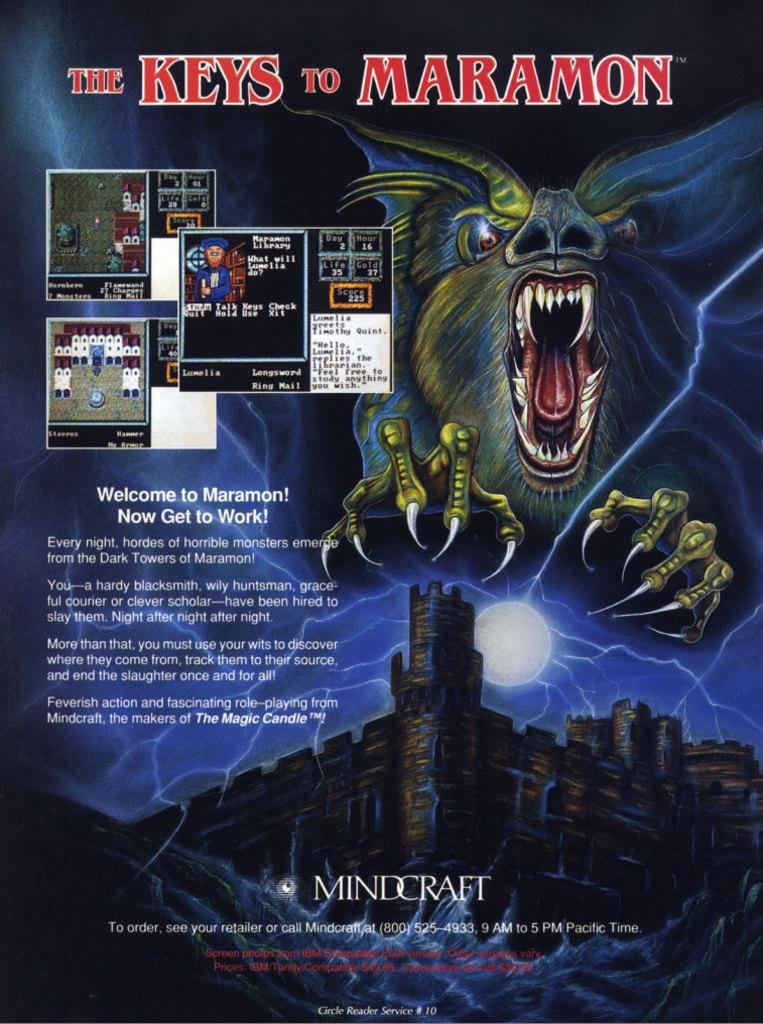Provide a one-sentence caption for the provided image. The back of a video game explains the game to the buyer. 